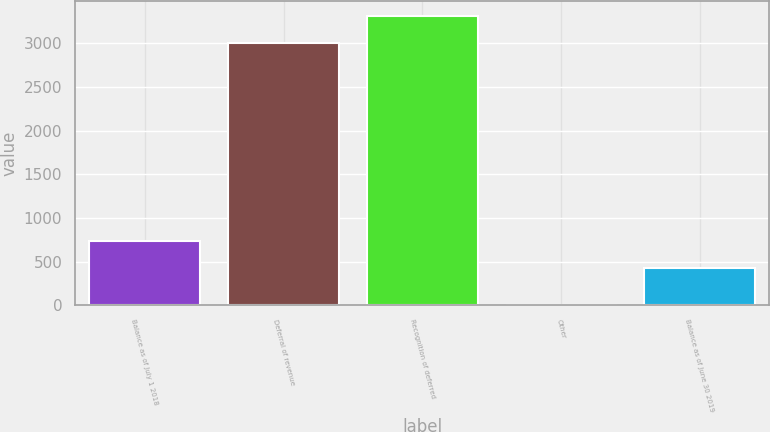Convert chart to OTSL. <chart><loc_0><loc_0><loc_500><loc_500><bar_chart><fcel>Balance as of July 1 2018<fcel>Deferral of revenue<fcel>Recognition of deferred<fcel>Other<fcel>Balance as of June 30 2019<nl><fcel>735.8<fcel>3008<fcel>3315.8<fcel>6<fcel>428<nl></chart> 